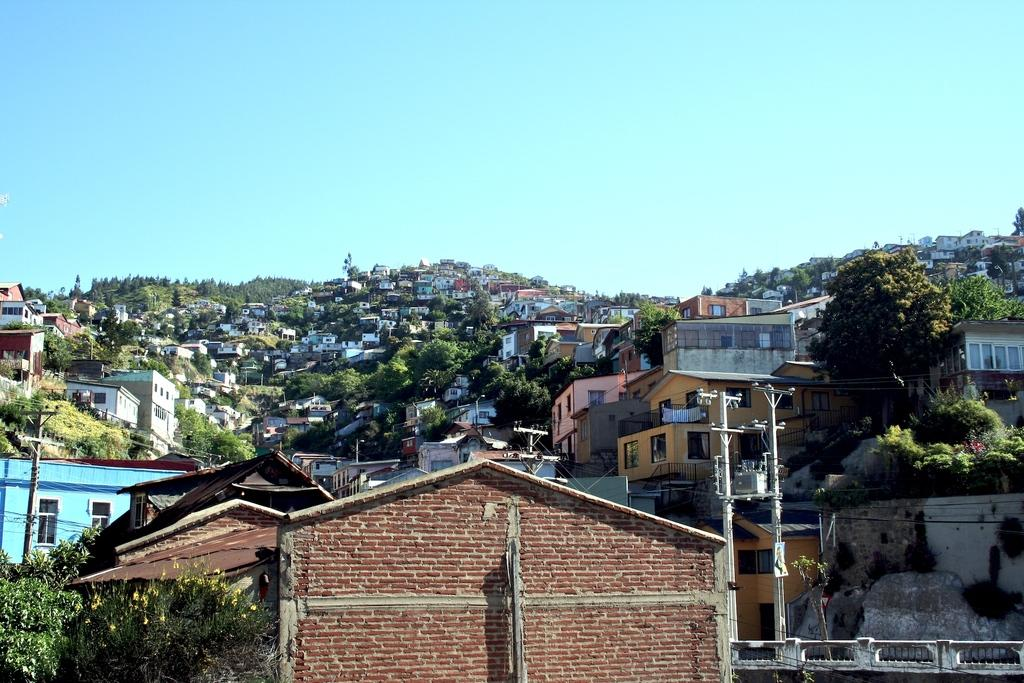What is the main subject in the center of the image? There is a building in the center of the image. What else can be seen in the center of the image besides the building? There are trees and poles in the center of the image. What can be seen in the background of the image? There are many houses, hills, trees, and the sky visible in the background of the image. What color is the orange in the image? There is no orange present in the image. Can you tell me how much the receipt costs in the image? There is no receipt present in the image. 